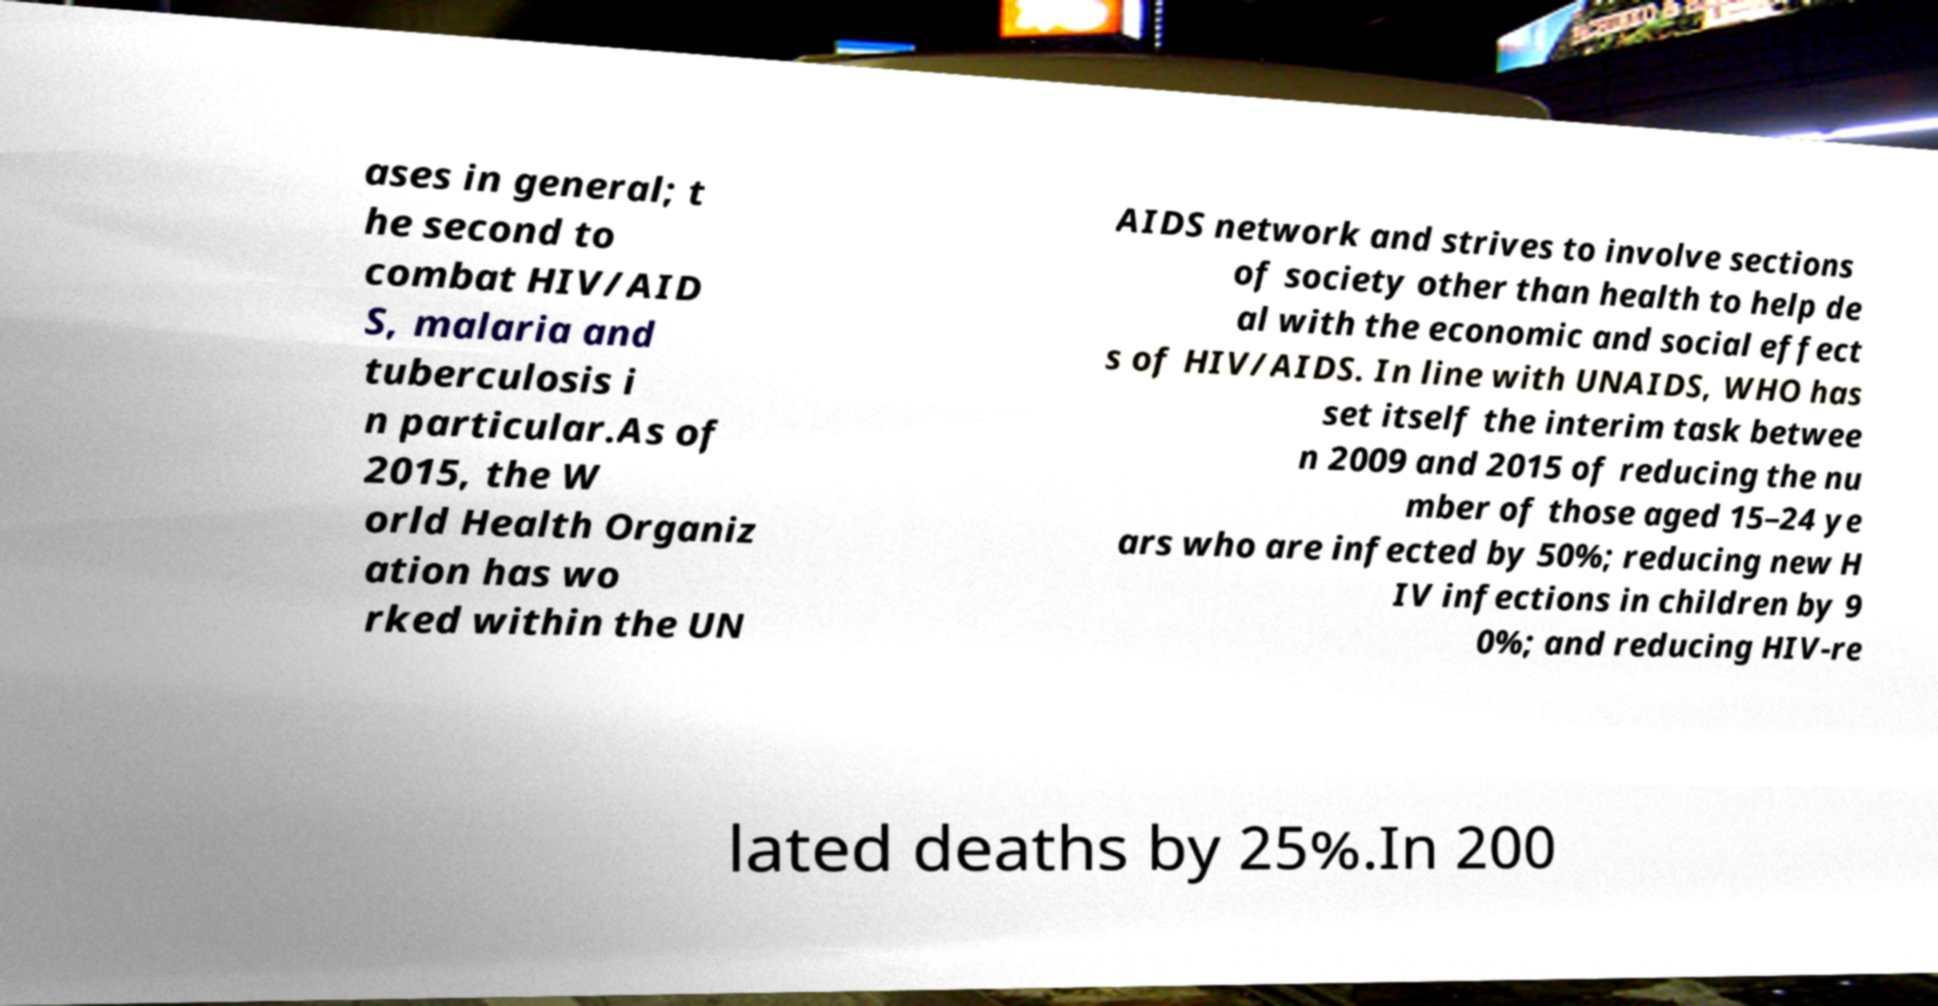Could you assist in decoding the text presented in this image and type it out clearly? ases in general; t he second to combat HIV/AID S, malaria and tuberculosis i n particular.As of 2015, the W orld Health Organiz ation has wo rked within the UN AIDS network and strives to involve sections of society other than health to help de al with the economic and social effect s of HIV/AIDS. In line with UNAIDS, WHO has set itself the interim task betwee n 2009 and 2015 of reducing the nu mber of those aged 15–24 ye ars who are infected by 50%; reducing new H IV infections in children by 9 0%; and reducing HIV-re lated deaths by 25%.In 200 